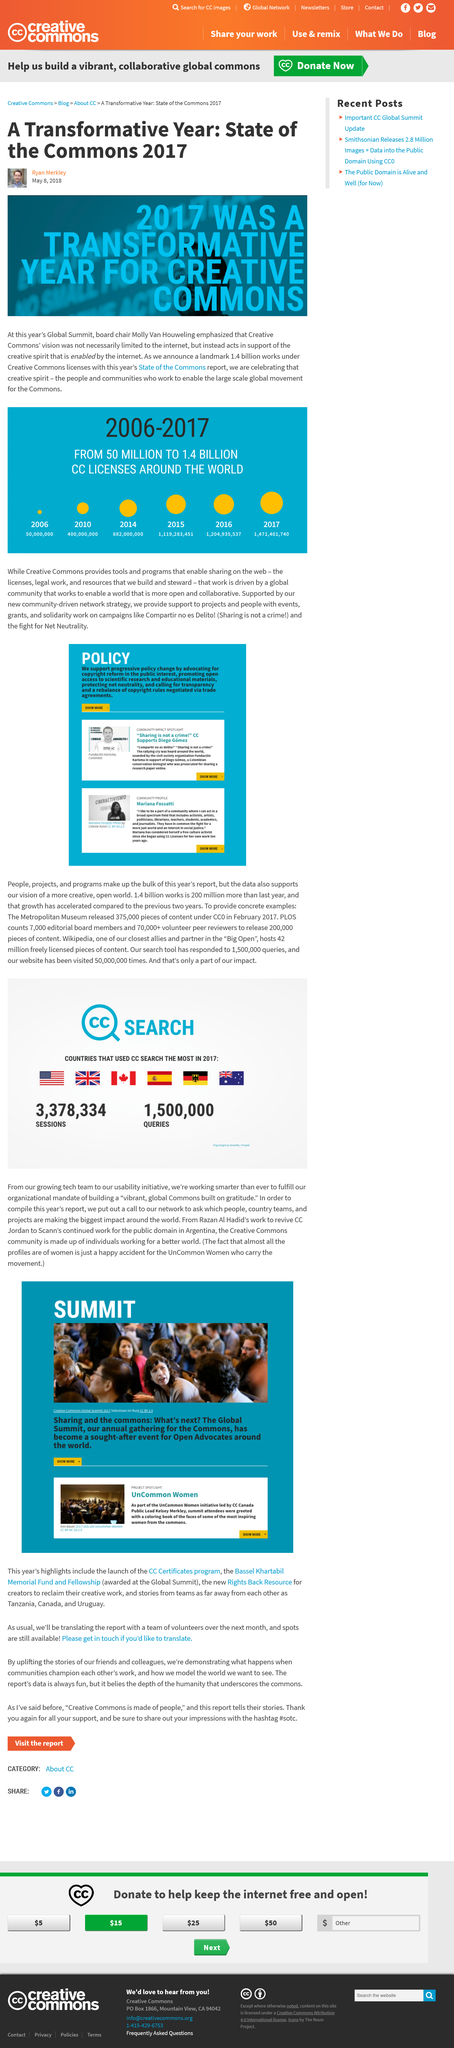Identify some key points in this picture. This was produced on May 8, 2018. The Global Summit is the annual gathering for the Commons. Creative Commons provides a range of tools and programs that enable the sharing of creative works on the web, including licenses, search tools, and other resources. These tools and programs allow individuals and organizations to easily share and reuse creative works while also protecting the rights of the creators. In 2017, approximately 1,500,000 queries took place. In 2014, there were 882,000,000 CC licenses in use. 